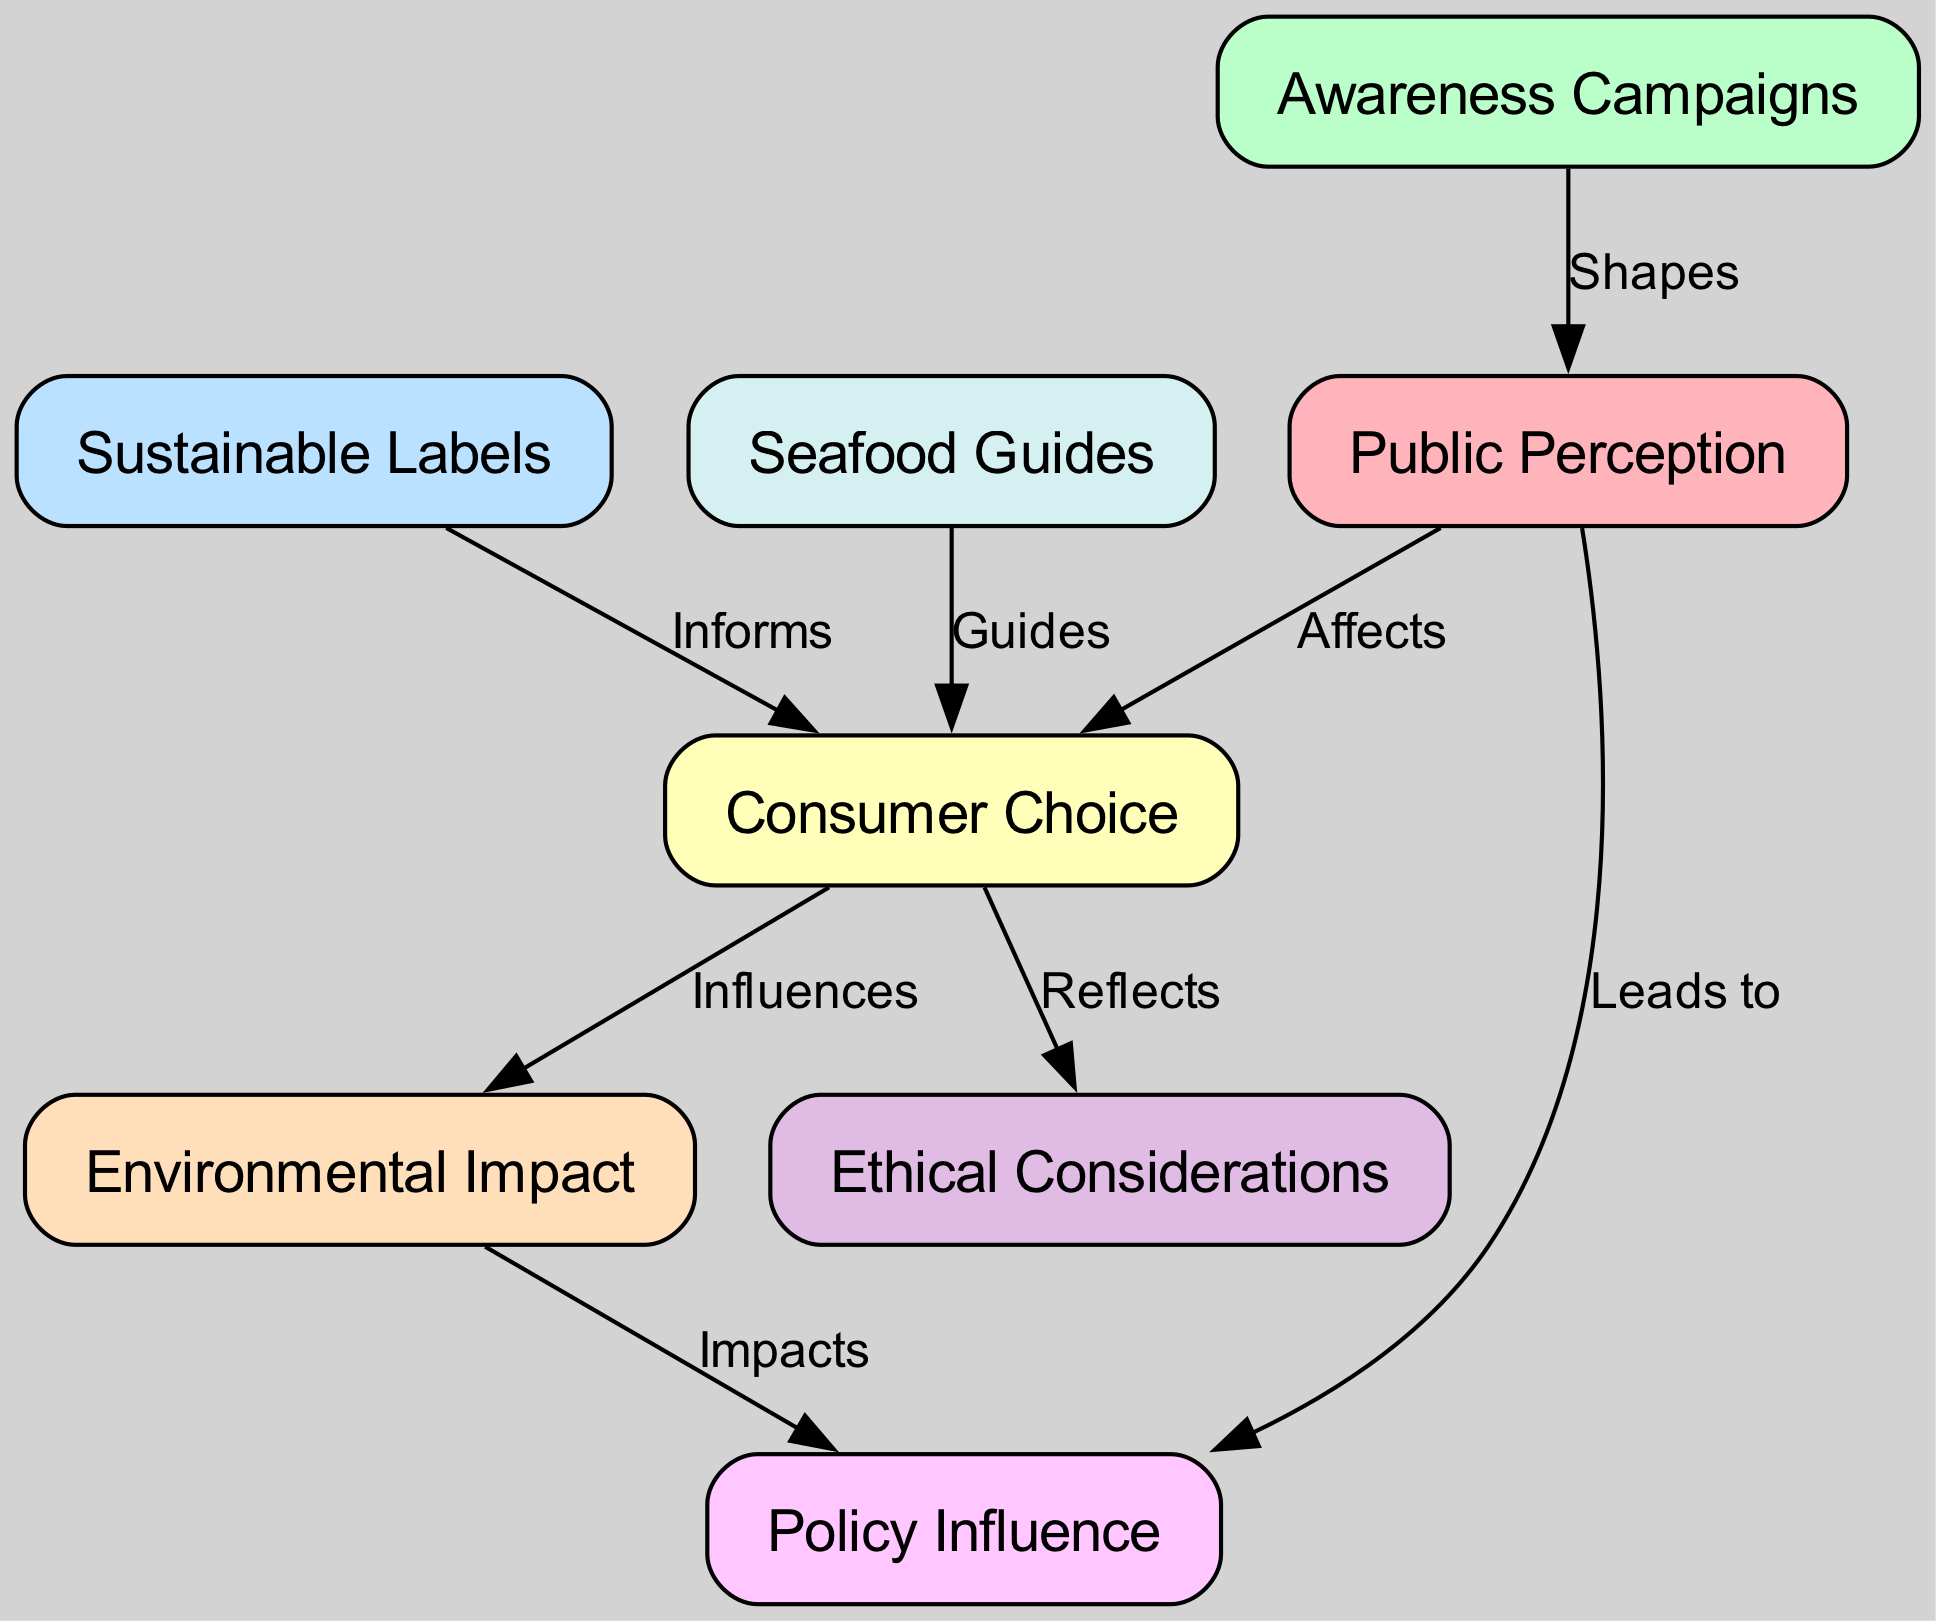What is the total number of nodes in the diagram? The diagram lists eight distinct nodes: public perception, awareness campaigns, sustainable labels, consumer choice, environmental impact, ethical considerations, seafood guides, and policy influence. Therefore, counting these gives us a total of eight nodes.
Answer: 8 What relationship exists between "awareness campaigns" and "public perception"? According to the diagram, awareness campaigns shape public perception, indicating a direct influence of campaigns on how the public views sustainable seafood practices.
Answer: Shapes Which node has a direct influence on "consumer choice"? The diagram specifies that sustainable labels, awareness campaigns, and seafood guides all inform or guide consumer choice, indicating multiple sources of influence. However, focusing on the direct influence from just one node, "sustainable labels" informs consumer choice.
Answer: Sustainable Labels How does "consumer choice" impact "environmental impact"? The diagram shows a directed edge from consumer choice to environmental impact, indicating that consumer choices regarding seafood directly influence its environmental impact. Therefore, analyzing the diagram confirms this relationship.
Answer: Influences What does the "public perception" lead to? The diagram illustrates that public perception leads to policy influence, indicating that how the public perceives sustainable seafood practices can have implications for policy-making.
Answer: Policy Influence What two nodes affect "ethical considerations"? According to the diagram, ethical considerations are reflected by consumer choice and can be derived from the overall public perception depicted in the flow. Thus, the two nodes that affect ethical considerations are "consumer choice" and "public perception."
Answer: Consumer Choice, Public Perception How do "environmental impact" and "public perception" relate to "policy influence"? The diagram shows that both environmental impact and public perception independently influence policy influence, which denotes that changes in environmental conditions or shifts in public opinion can affect policy decisions concerning seafood.
Answer: Impacts, Leads to What influences "consumer choice"? The diagram identifies several influences on consumer choice, including awareness campaigns, sustainable labels, and seafood guides, highlighting that these factors collectively inform consumer decisions regarding seafood.
Answer: Awareness Campaigns, Sustainable Labels, Seafood Guides What role do seafood guides play in the diagram? The diagram emphasizes that seafood guides guide consumer choice, indicating that they serve as a resource for consumers when making decisions about sustainable seafood options.
Answer: Guides 